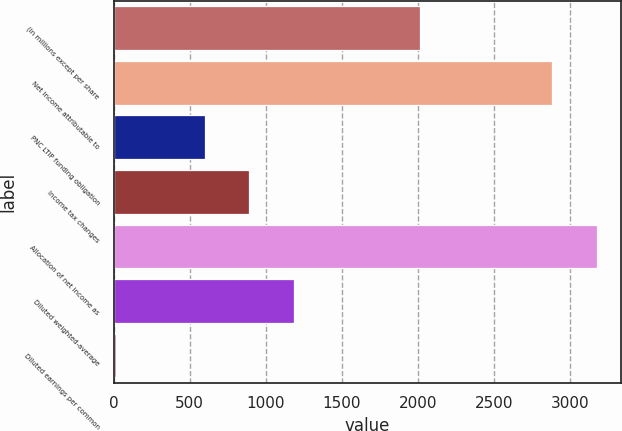Convert chart to OTSL. <chart><loc_0><loc_0><loc_500><loc_500><bar_chart><fcel>(in millions except per share<fcel>Net income attributable to<fcel>PNC LTIP funding obligation<fcel>Income tax changes<fcel>Allocation of net income as<fcel>Diluted weighted-average<fcel>Diluted earnings per common<nl><fcel>2013<fcel>2882<fcel>599.66<fcel>891.2<fcel>3173.54<fcel>1182.74<fcel>16.58<nl></chart> 